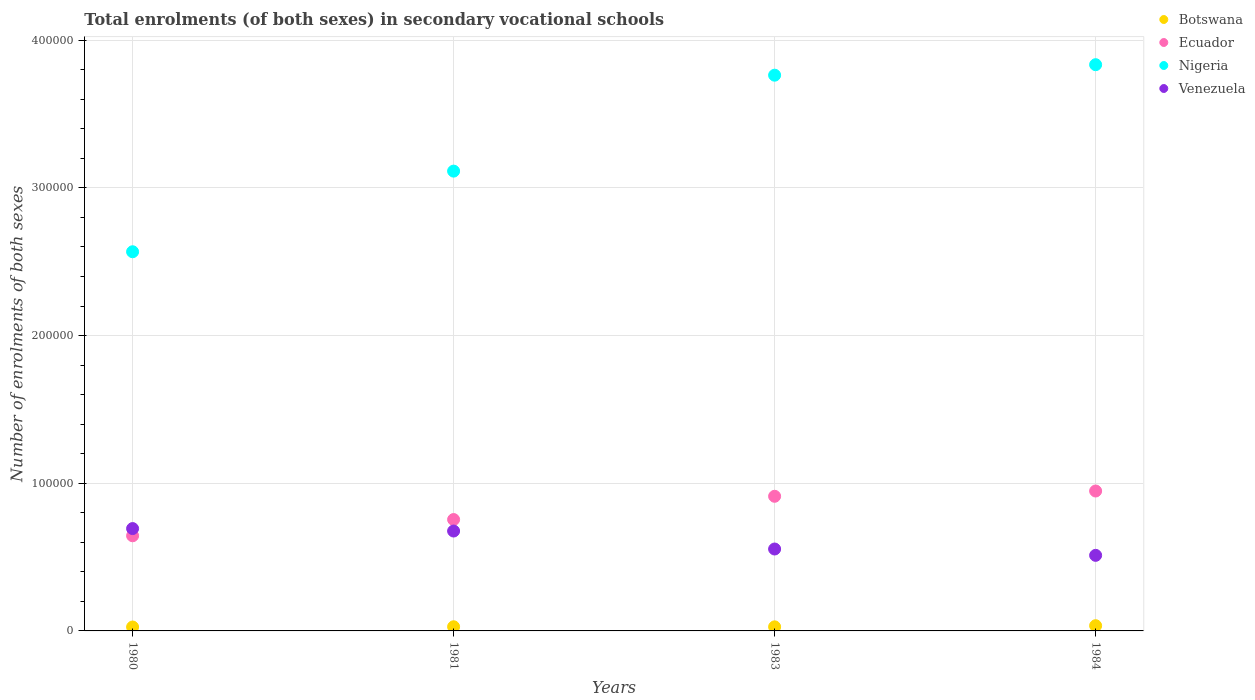How many different coloured dotlines are there?
Your response must be concise. 4. Is the number of dotlines equal to the number of legend labels?
Your answer should be very brief. Yes. What is the number of enrolments in secondary schools in Botswana in 1980?
Provide a short and direct response. 2644. Across all years, what is the maximum number of enrolments in secondary schools in Venezuela?
Ensure brevity in your answer.  6.93e+04. Across all years, what is the minimum number of enrolments in secondary schools in Venezuela?
Make the answer very short. 5.12e+04. What is the total number of enrolments in secondary schools in Venezuela in the graph?
Your answer should be compact. 2.44e+05. What is the difference between the number of enrolments in secondary schools in Ecuador in 1980 and that in 1984?
Keep it short and to the point. -3.03e+04. What is the difference between the number of enrolments in secondary schools in Venezuela in 1984 and the number of enrolments in secondary schools in Ecuador in 1983?
Offer a terse response. -4.00e+04. What is the average number of enrolments in secondary schools in Nigeria per year?
Provide a short and direct response. 3.32e+05. In the year 1983, what is the difference between the number of enrolments in secondary schools in Botswana and number of enrolments in secondary schools in Ecuador?
Your response must be concise. -8.84e+04. In how many years, is the number of enrolments in secondary schools in Nigeria greater than 340000?
Offer a terse response. 2. What is the ratio of the number of enrolments in secondary schools in Ecuador in 1983 to that in 1984?
Your response must be concise. 0.96. Is the number of enrolments in secondary schools in Nigeria in 1981 less than that in 1983?
Give a very brief answer. Yes. Is the difference between the number of enrolments in secondary schools in Botswana in 1981 and 1984 greater than the difference between the number of enrolments in secondary schools in Ecuador in 1981 and 1984?
Your response must be concise. Yes. What is the difference between the highest and the second highest number of enrolments in secondary schools in Ecuador?
Offer a terse response. 3574. What is the difference between the highest and the lowest number of enrolments in secondary schools in Nigeria?
Ensure brevity in your answer.  1.27e+05. Is it the case that in every year, the sum of the number of enrolments in secondary schools in Ecuador and number of enrolments in secondary schools in Nigeria  is greater than the number of enrolments in secondary schools in Botswana?
Give a very brief answer. Yes. Does the number of enrolments in secondary schools in Botswana monotonically increase over the years?
Your answer should be compact. No. What is the difference between two consecutive major ticks on the Y-axis?
Your answer should be very brief. 1.00e+05. Where does the legend appear in the graph?
Provide a short and direct response. Top right. How many legend labels are there?
Your answer should be compact. 4. What is the title of the graph?
Your answer should be very brief. Total enrolments (of both sexes) in secondary vocational schools. What is the label or title of the X-axis?
Offer a very short reply. Years. What is the label or title of the Y-axis?
Keep it short and to the point. Number of enrolments of both sexes. What is the Number of enrolments of both sexes of Botswana in 1980?
Ensure brevity in your answer.  2644. What is the Number of enrolments of both sexes in Ecuador in 1980?
Ensure brevity in your answer.  6.44e+04. What is the Number of enrolments of both sexes of Nigeria in 1980?
Make the answer very short. 2.57e+05. What is the Number of enrolments of both sexes in Venezuela in 1980?
Provide a short and direct response. 6.93e+04. What is the Number of enrolments of both sexes in Botswana in 1981?
Offer a terse response. 2814. What is the Number of enrolments of both sexes in Ecuador in 1981?
Provide a succinct answer. 7.54e+04. What is the Number of enrolments of both sexes in Nigeria in 1981?
Keep it short and to the point. 3.11e+05. What is the Number of enrolments of both sexes of Venezuela in 1981?
Provide a short and direct response. 6.76e+04. What is the Number of enrolments of both sexes in Botswana in 1983?
Keep it short and to the point. 2758. What is the Number of enrolments of both sexes of Ecuador in 1983?
Your response must be concise. 9.12e+04. What is the Number of enrolments of both sexes in Nigeria in 1983?
Offer a terse response. 3.76e+05. What is the Number of enrolments of both sexes in Venezuela in 1983?
Offer a very short reply. 5.55e+04. What is the Number of enrolments of both sexes in Botswana in 1984?
Your answer should be compact. 3538. What is the Number of enrolments of both sexes of Ecuador in 1984?
Offer a very short reply. 9.47e+04. What is the Number of enrolments of both sexes of Nigeria in 1984?
Your answer should be very brief. 3.83e+05. What is the Number of enrolments of both sexes of Venezuela in 1984?
Provide a short and direct response. 5.12e+04. Across all years, what is the maximum Number of enrolments of both sexes in Botswana?
Give a very brief answer. 3538. Across all years, what is the maximum Number of enrolments of both sexes of Ecuador?
Offer a terse response. 9.47e+04. Across all years, what is the maximum Number of enrolments of both sexes in Nigeria?
Offer a terse response. 3.83e+05. Across all years, what is the maximum Number of enrolments of both sexes in Venezuela?
Make the answer very short. 6.93e+04. Across all years, what is the minimum Number of enrolments of both sexes in Botswana?
Your answer should be very brief. 2644. Across all years, what is the minimum Number of enrolments of both sexes of Ecuador?
Make the answer very short. 6.44e+04. Across all years, what is the minimum Number of enrolments of both sexes of Nigeria?
Ensure brevity in your answer.  2.57e+05. Across all years, what is the minimum Number of enrolments of both sexes in Venezuela?
Offer a terse response. 5.12e+04. What is the total Number of enrolments of both sexes of Botswana in the graph?
Make the answer very short. 1.18e+04. What is the total Number of enrolments of both sexes of Ecuador in the graph?
Offer a very short reply. 3.26e+05. What is the total Number of enrolments of both sexes in Nigeria in the graph?
Your answer should be very brief. 1.33e+06. What is the total Number of enrolments of both sexes in Venezuela in the graph?
Your answer should be very brief. 2.44e+05. What is the difference between the Number of enrolments of both sexes of Botswana in 1980 and that in 1981?
Provide a short and direct response. -170. What is the difference between the Number of enrolments of both sexes of Ecuador in 1980 and that in 1981?
Your answer should be compact. -1.10e+04. What is the difference between the Number of enrolments of both sexes of Nigeria in 1980 and that in 1981?
Give a very brief answer. -5.46e+04. What is the difference between the Number of enrolments of both sexes of Venezuela in 1980 and that in 1981?
Make the answer very short. 1663. What is the difference between the Number of enrolments of both sexes in Botswana in 1980 and that in 1983?
Make the answer very short. -114. What is the difference between the Number of enrolments of both sexes in Ecuador in 1980 and that in 1983?
Offer a terse response. -2.67e+04. What is the difference between the Number of enrolments of both sexes of Nigeria in 1980 and that in 1983?
Ensure brevity in your answer.  -1.20e+05. What is the difference between the Number of enrolments of both sexes of Venezuela in 1980 and that in 1983?
Make the answer very short. 1.38e+04. What is the difference between the Number of enrolments of both sexes in Botswana in 1980 and that in 1984?
Make the answer very short. -894. What is the difference between the Number of enrolments of both sexes of Ecuador in 1980 and that in 1984?
Give a very brief answer. -3.03e+04. What is the difference between the Number of enrolments of both sexes of Nigeria in 1980 and that in 1984?
Offer a very short reply. -1.27e+05. What is the difference between the Number of enrolments of both sexes in Venezuela in 1980 and that in 1984?
Provide a short and direct response. 1.81e+04. What is the difference between the Number of enrolments of both sexes in Botswana in 1981 and that in 1983?
Offer a very short reply. 56. What is the difference between the Number of enrolments of both sexes in Ecuador in 1981 and that in 1983?
Offer a terse response. -1.58e+04. What is the difference between the Number of enrolments of both sexes in Nigeria in 1981 and that in 1983?
Provide a short and direct response. -6.50e+04. What is the difference between the Number of enrolments of both sexes in Venezuela in 1981 and that in 1983?
Your response must be concise. 1.22e+04. What is the difference between the Number of enrolments of both sexes of Botswana in 1981 and that in 1984?
Offer a very short reply. -724. What is the difference between the Number of enrolments of both sexes of Ecuador in 1981 and that in 1984?
Ensure brevity in your answer.  -1.93e+04. What is the difference between the Number of enrolments of both sexes of Nigeria in 1981 and that in 1984?
Give a very brief answer. -7.21e+04. What is the difference between the Number of enrolments of both sexes in Venezuela in 1981 and that in 1984?
Offer a very short reply. 1.65e+04. What is the difference between the Number of enrolments of both sexes of Botswana in 1983 and that in 1984?
Keep it short and to the point. -780. What is the difference between the Number of enrolments of both sexes of Ecuador in 1983 and that in 1984?
Provide a short and direct response. -3574. What is the difference between the Number of enrolments of both sexes of Nigeria in 1983 and that in 1984?
Give a very brief answer. -7107. What is the difference between the Number of enrolments of both sexes in Venezuela in 1983 and that in 1984?
Provide a short and direct response. 4288. What is the difference between the Number of enrolments of both sexes of Botswana in 1980 and the Number of enrolments of both sexes of Ecuador in 1981?
Your answer should be very brief. -7.28e+04. What is the difference between the Number of enrolments of both sexes of Botswana in 1980 and the Number of enrolments of both sexes of Nigeria in 1981?
Your response must be concise. -3.09e+05. What is the difference between the Number of enrolments of both sexes of Botswana in 1980 and the Number of enrolments of both sexes of Venezuela in 1981?
Give a very brief answer. -6.50e+04. What is the difference between the Number of enrolments of both sexes of Ecuador in 1980 and the Number of enrolments of both sexes of Nigeria in 1981?
Give a very brief answer. -2.47e+05. What is the difference between the Number of enrolments of both sexes of Ecuador in 1980 and the Number of enrolments of both sexes of Venezuela in 1981?
Your answer should be compact. -3208. What is the difference between the Number of enrolments of both sexes in Nigeria in 1980 and the Number of enrolments of both sexes in Venezuela in 1981?
Keep it short and to the point. 1.89e+05. What is the difference between the Number of enrolments of both sexes of Botswana in 1980 and the Number of enrolments of both sexes of Ecuador in 1983?
Your answer should be very brief. -8.85e+04. What is the difference between the Number of enrolments of both sexes of Botswana in 1980 and the Number of enrolments of both sexes of Nigeria in 1983?
Your answer should be very brief. -3.74e+05. What is the difference between the Number of enrolments of both sexes of Botswana in 1980 and the Number of enrolments of both sexes of Venezuela in 1983?
Provide a succinct answer. -5.28e+04. What is the difference between the Number of enrolments of both sexes of Ecuador in 1980 and the Number of enrolments of both sexes of Nigeria in 1983?
Your response must be concise. -3.12e+05. What is the difference between the Number of enrolments of both sexes in Ecuador in 1980 and the Number of enrolments of both sexes in Venezuela in 1983?
Provide a short and direct response. 8967. What is the difference between the Number of enrolments of both sexes in Nigeria in 1980 and the Number of enrolments of both sexes in Venezuela in 1983?
Your answer should be compact. 2.01e+05. What is the difference between the Number of enrolments of both sexes of Botswana in 1980 and the Number of enrolments of both sexes of Ecuador in 1984?
Offer a terse response. -9.21e+04. What is the difference between the Number of enrolments of both sexes in Botswana in 1980 and the Number of enrolments of both sexes in Nigeria in 1984?
Ensure brevity in your answer.  -3.81e+05. What is the difference between the Number of enrolments of both sexes in Botswana in 1980 and the Number of enrolments of both sexes in Venezuela in 1984?
Keep it short and to the point. -4.85e+04. What is the difference between the Number of enrolments of both sexes in Ecuador in 1980 and the Number of enrolments of both sexes in Nigeria in 1984?
Make the answer very short. -3.19e+05. What is the difference between the Number of enrolments of both sexes in Ecuador in 1980 and the Number of enrolments of both sexes in Venezuela in 1984?
Offer a very short reply. 1.33e+04. What is the difference between the Number of enrolments of both sexes in Nigeria in 1980 and the Number of enrolments of both sexes in Venezuela in 1984?
Your answer should be very brief. 2.06e+05. What is the difference between the Number of enrolments of both sexes in Botswana in 1981 and the Number of enrolments of both sexes in Ecuador in 1983?
Your answer should be very brief. -8.84e+04. What is the difference between the Number of enrolments of both sexes of Botswana in 1981 and the Number of enrolments of both sexes of Nigeria in 1983?
Make the answer very short. -3.74e+05. What is the difference between the Number of enrolments of both sexes of Botswana in 1981 and the Number of enrolments of both sexes of Venezuela in 1983?
Provide a short and direct response. -5.27e+04. What is the difference between the Number of enrolments of both sexes of Ecuador in 1981 and the Number of enrolments of both sexes of Nigeria in 1983?
Your answer should be very brief. -3.01e+05. What is the difference between the Number of enrolments of both sexes of Ecuador in 1981 and the Number of enrolments of both sexes of Venezuela in 1983?
Make the answer very short. 2.00e+04. What is the difference between the Number of enrolments of both sexes in Nigeria in 1981 and the Number of enrolments of both sexes in Venezuela in 1983?
Your answer should be compact. 2.56e+05. What is the difference between the Number of enrolments of both sexes in Botswana in 1981 and the Number of enrolments of both sexes in Ecuador in 1984?
Offer a terse response. -9.19e+04. What is the difference between the Number of enrolments of both sexes in Botswana in 1981 and the Number of enrolments of both sexes in Nigeria in 1984?
Ensure brevity in your answer.  -3.81e+05. What is the difference between the Number of enrolments of both sexes in Botswana in 1981 and the Number of enrolments of both sexes in Venezuela in 1984?
Provide a short and direct response. -4.84e+04. What is the difference between the Number of enrolments of both sexes in Ecuador in 1981 and the Number of enrolments of both sexes in Nigeria in 1984?
Offer a terse response. -3.08e+05. What is the difference between the Number of enrolments of both sexes of Ecuador in 1981 and the Number of enrolments of both sexes of Venezuela in 1984?
Give a very brief answer. 2.42e+04. What is the difference between the Number of enrolments of both sexes in Nigeria in 1981 and the Number of enrolments of both sexes in Venezuela in 1984?
Ensure brevity in your answer.  2.60e+05. What is the difference between the Number of enrolments of both sexes in Botswana in 1983 and the Number of enrolments of both sexes in Ecuador in 1984?
Your answer should be very brief. -9.20e+04. What is the difference between the Number of enrolments of both sexes of Botswana in 1983 and the Number of enrolments of both sexes of Nigeria in 1984?
Keep it short and to the point. -3.81e+05. What is the difference between the Number of enrolments of both sexes in Botswana in 1983 and the Number of enrolments of both sexes in Venezuela in 1984?
Offer a terse response. -4.84e+04. What is the difference between the Number of enrolments of both sexes in Ecuador in 1983 and the Number of enrolments of both sexes in Nigeria in 1984?
Make the answer very short. -2.92e+05. What is the difference between the Number of enrolments of both sexes in Ecuador in 1983 and the Number of enrolments of both sexes in Venezuela in 1984?
Your response must be concise. 4.00e+04. What is the difference between the Number of enrolments of both sexes of Nigeria in 1983 and the Number of enrolments of both sexes of Venezuela in 1984?
Give a very brief answer. 3.25e+05. What is the average Number of enrolments of both sexes in Botswana per year?
Provide a short and direct response. 2938.5. What is the average Number of enrolments of both sexes of Ecuador per year?
Give a very brief answer. 8.14e+04. What is the average Number of enrolments of both sexes in Nigeria per year?
Your answer should be very brief. 3.32e+05. What is the average Number of enrolments of both sexes of Venezuela per year?
Keep it short and to the point. 6.09e+04. In the year 1980, what is the difference between the Number of enrolments of both sexes in Botswana and Number of enrolments of both sexes in Ecuador?
Ensure brevity in your answer.  -6.18e+04. In the year 1980, what is the difference between the Number of enrolments of both sexes in Botswana and Number of enrolments of both sexes in Nigeria?
Offer a terse response. -2.54e+05. In the year 1980, what is the difference between the Number of enrolments of both sexes in Botswana and Number of enrolments of both sexes in Venezuela?
Provide a succinct answer. -6.67e+04. In the year 1980, what is the difference between the Number of enrolments of both sexes in Ecuador and Number of enrolments of both sexes in Nigeria?
Your response must be concise. -1.92e+05. In the year 1980, what is the difference between the Number of enrolments of both sexes in Ecuador and Number of enrolments of both sexes in Venezuela?
Your answer should be compact. -4871. In the year 1980, what is the difference between the Number of enrolments of both sexes of Nigeria and Number of enrolments of both sexes of Venezuela?
Your answer should be very brief. 1.87e+05. In the year 1981, what is the difference between the Number of enrolments of both sexes in Botswana and Number of enrolments of both sexes in Ecuador?
Make the answer very short. -7.26e+04. In the year 1981, what is the difference between the Number of enrolments of both sexes in Botswana and Number of enrolments of both sexes in Nigeria?
Offer a very short reply. -3.09e+05. In the year 1981, what is the difference between the Number of enrolments of both sexes in Botswana and Number of enrolments of both sexes in Venezuela?
Your answer should be compact. -6.48e+04. In the year 1981, what is the difference between the Number of enrolments of both sexes of Ecuador and Number of enrolments of both sexes of Nigeria?
Provide a succinct answer. -2.36e+05. In the year 1981, what is the difference between the Number of enrolments of both sexes of Ecuador and Number of enrolments of both sexes of Venezuela?
Ensure brevity in your answer.  7780. In the year 1981, what is the difference between the Number of enrolments of both sexes in Nigeria and Number of enrolments of both sexes in Venezuela?
Keep it short and to the point. 2.44e+05. In the year 1983, what is the difference between the Number of enrolments of both sexes of Botswana and Number of enrolments of both sexes of Ecuador?
Keep it short and to the point. -8.84e+04. In the year 1983, what is the difference between the Number of enrolments of both sexes in Botswana and Number of enrolments of both sexes in Nigeria?
Make the answer very short. -3.74e+05. In the year 1983, what is the difference between the Number of enrolments of both sexes in Botswana and Number of enrolments of both sexes in Venezuela?
Offer a terse response. -5.27e+04. In the year 1983, what is the difference between the Number of enrolments of both sexes in Ecuador and Number of enrolments of both sexes in Nigeria?
Give a very brief answer. -2.85e+05. In the year 1983, what is the difference between the Number of enrolments of both sexes in Ecuador and Number of enrolments of both sexes in Venezuela?
Your answer should be very brief. 3.57e+04. In the year 1983, what is the difference between the Number of enrolments of both sexes of Nigeria and Number of enrolments of both sexes of Venezuela?
Keep it short and to the point. 3.21e+05. In the year 1984, what is the difference between the Number of enrolments of both sexes of Botswana and Number of enrolments of both sexes of Ecuador?
Keep it short and to the point. -9.12e+04. In the year 1984, what is the difference between the Number of enrolments of both sexes of Botswana and Number of enrolments of both sexes of Nigeria?
Offer a terse response. -3.80e+05. In the year 1984, what is the difference between the Number of enrolments of both sexes in Botswana and Number of enrolments of both sexes in Venezuela?
Your answer should be compact. -4.76e+04. In the year 1984, what is the difference between the Number of enrolments of both sexes in Ecuador and Number of enrolments of both sexes in Nigeria?
Offer a very short reply. -2.89e+05. In the year 1984, what is the difference between the Number of enrolments of both sexes in Ecuador and Number of enrolments of both sexes in Venezuela?
Ensure brevity in your answer.  4.36e+04. In the year 1984, what is the difference between the Number of enrolments of both sexes of Nigeria and Number of enrolments of both sexes of Venezuela?
Your response must be concise. 3.32e+05. What is the ratio of the Number of enrolments of both sexes of Botswana in 1980 to that in 1981?
Offer a very short reply. 0.94. What is the ratio of the Number of enrolments of both sexes in Ecuador in 1980 to that in 1981?
Keep it short and to the point. 0.85. What is the ratio of the Number of enrolments of both sexes of Nigeria in 1980 to that in 1981?
Provide a short and direct response. 0.82. What is the ratio of the Number of enrolments of both sexes in Venezuela in 1980 to that in 1981?
Provide a succinct answer. 1.02. What is the ratio of the Number of enrolments of both sexes in Botswana in 1980 to that in 1983?
Provide a succinct answer. 0.96. What is the ratio of the Number of enrolments of both sexes of Ecuador in 1980 to that in 1983?
Offer a very short reply. 0.71. What is the ratio of the Number of enrolments of both sexes of Nigeria in 1980 to that in 1983?
Make the answer very short. 0.68. What is the ratio of the Number of enrolments of both sexes in Venezuela in 1980 to that in 1983?
Ensure brevity in your answer.  1.25. What is the ratio of the Number of enrolments of both sexes of Botswana in 1980 to that in 1984?
Offer a very short reply. 0.75. What is the ratio of the Number of enrolments of both sexes in Ecuador in 1980 to that in 1984?
Your answer should be very brief. 0.68. What is the ratio of the Number of enrolments of both sexes in Nigeria in 1980 to that in 1984?
Provide a succinct answer. 0.67. What is the ratio of the Number of enrolments of both sexes in Venezuela in 1980 to that in 1984?
Provide a succinct answer. 1.35. What is the ratio of the Number of enrolments of both sexes of Botswana in 1981 to that in 1983?
Provide a short and direct response. 1.02. What is the ratio of the Number of enrolments of both sexes in Ecuador in 1981 to that in 1983?
Your answer should be compact. 0.83. What is the ratio of the Number of enrolments of both sexes of Nigeria in 1981 to that in 1983?
Give a very brief answer. 0.83. What is the ratio of the Number of enrolments of both sexes of Venezuela in 1981 to that in 1983?
Your answer should be very brief. 1.22. What is the ratio of the Number of enrolments of both sexes of Botswana in 1981 to that in 1984?
Make the answer very short. 0.8. What is the ratio of the Number of enrolments of both sexes of Ecuador in 1981 to that in 1984?
Provide a succinct answer. 0.8. What is the ratio of the Number of enrolments of both sexes of Nigeria in 1981 to that in 1984?
Your answer should be very brief. 0.81. What is the ratio of the Number of enrolments of both sexes in Venezuela in 1981 to that in 1984?
Provide a succinct answer. 1.32. What is the ratio of the Number of enrolments of both sexes of Botswana in 1983 to that in 1984?
Ensure brevity in your answer.  0.78. What is the ratio of the Number of enrolments of both sexes in Ecuador in 1983 to that in 1984?
Provide a short and direct response. 0.96. What is the ratio of the Number of enrolments of both sexes of Nigeria in 1983 to that in 1984?
Offer a terse response. 0.98. What is the ratio of the Number of enrolments of both sexes of Venezuela in 1983 to that in 1984?
Your answer should be very brief. 1.08. What is the difference between the highest and the second highest Number of enrolments of both sexes in Botswana?
Offer a terse response. 724. What is the difference between the highest and the second highest Number of enrolments of both sexes of Ecuador?
Offer a very short reply. 3574. What is the difference between the highest and the second highest Number of enrolments of both sexes of Nigeria?
Give a very brief answer. 7107. What is the difference between the highest and the second highest Number of enrolments of both sexes in Venezuela?
Offer a very short reply. 1663. What is the difference between the highest and the lowest Number of enrolments of both sexes of Botswana?
Offer a terse response. 894. What is the difference between the highest and the lowest Number of enrolments of both sexes of Ecuador?
Provide a succinct answer. 3.03e+04. What is the difference between the highest and the lowest Number of enrolments of both sexes in Nigeria?
Make the answer very short. 1.27e+05. What is the difference between the highest and the lowest Number of enrolments of both sexes of Venezuela?
Your answer should be very brief. 1.81e+04. 